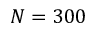<formula> <loc_0><loc_0><loc_500><loc_500>N = 3 0 0</formula> 